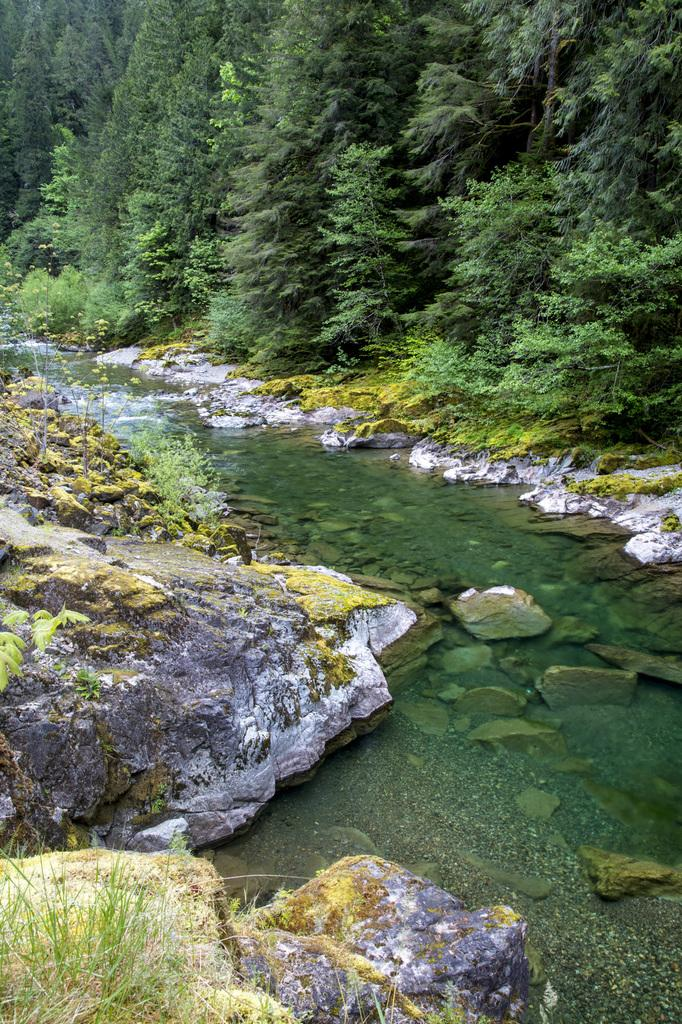What is the main feature in the center of the image? There is water in the center of the image. What can be seen on the right side of the image? There are rocks on the right side of the image. What is present on the left side of the image? There are rocks on the left side of the image. What type of natural scenery is visible in the background of the image? There are trees in the background of the image. What type of apparel is being worn by the zephyr in the image? There is no zephyr or apparel present in the image. A zephyr is a gentle breeze, which cannot wear clothing. 